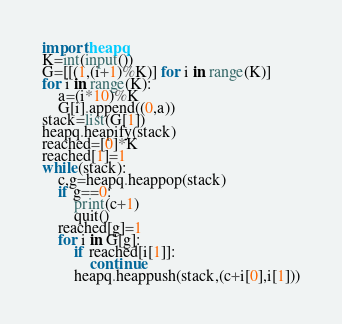Convert code to text. <code><loc_0><loc_0><loc_500><loc_500><_Python_>import heapq
K=int(input())
G=[[(1,(i+1)%K)] for i in range(K)]
for i in range(K):
    a=(i*10)%K
    G[i].append((0,a))
stack=list(G[1])
heapq.heapify(stack)
reached=[0]*K
reached[1]=1
while(stack):
    c,g=heapq.heappop(stack)
    if g==0:
        print(c+1)
        quit()
    reached[g]=1
    for i in G[g]:
        if reached[i[1]]:
            continue
        heapq.heappush(stack,(c+i[0],i[1]))
</code> 